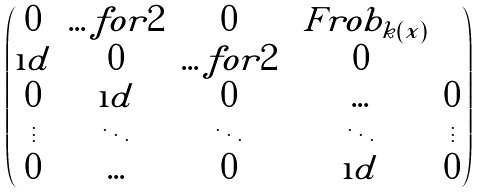Convert formula to latex. <formula><loc_0><loc_0><loc_500><loc_500>\begin{pmatrix} 0 & \hdots f o r { 2 } & 0 & \ F r o b _ { k ( x ) } \\ \i d & 0 & \hdots f o r { 2 } & 0 \\ 0 & \i d & 0 & \hdots & 0 \\ \vdots & \ddots & \ddots & \ddots & \vdots \\ 0 & \hdots & 0 & \i d & 0 \end{pmatrix}</formula> 